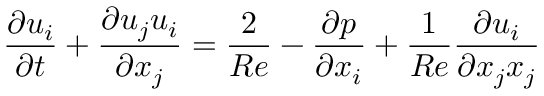Convert formula to latex. <formula><loc_0><loc_0><loc_500><loc_500>\frac { \partial u _ { i } } { \partial t } + \frac { \partial u _ { j } u _ { i } } { \partial x _ { j } } = \frac { 2 } { R e } - \frac { \partial p } { \partial x _ { i } } + \frac { 1 } { R e } \frac { \partial u _ { i } } { \partial x _ { j } x _ { j } }</formula> 